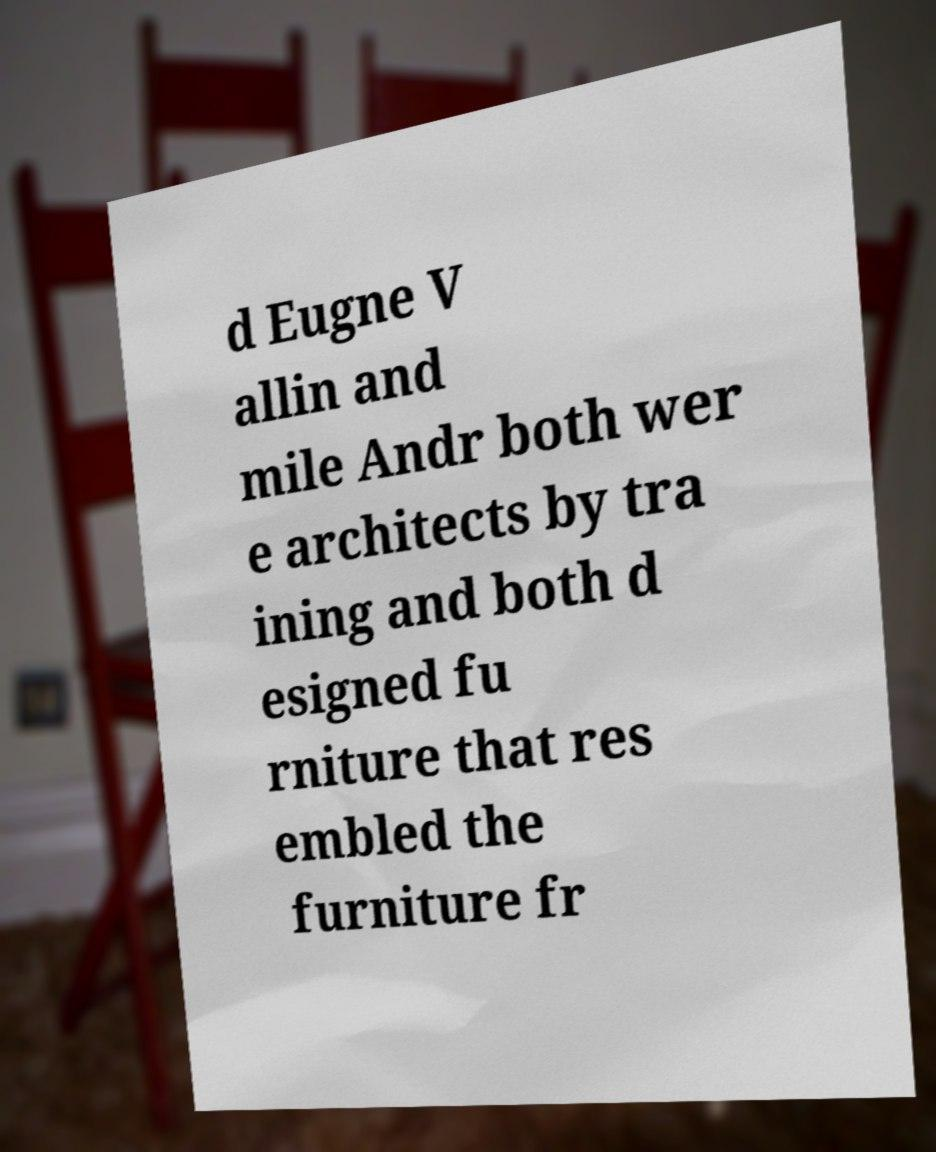Can you accurately transcribe the text from the provided image for me? d Eugne V allin and mile Andr both wer e architects by tra ining and both d esigned fu rniture that res embled the furniture fr 